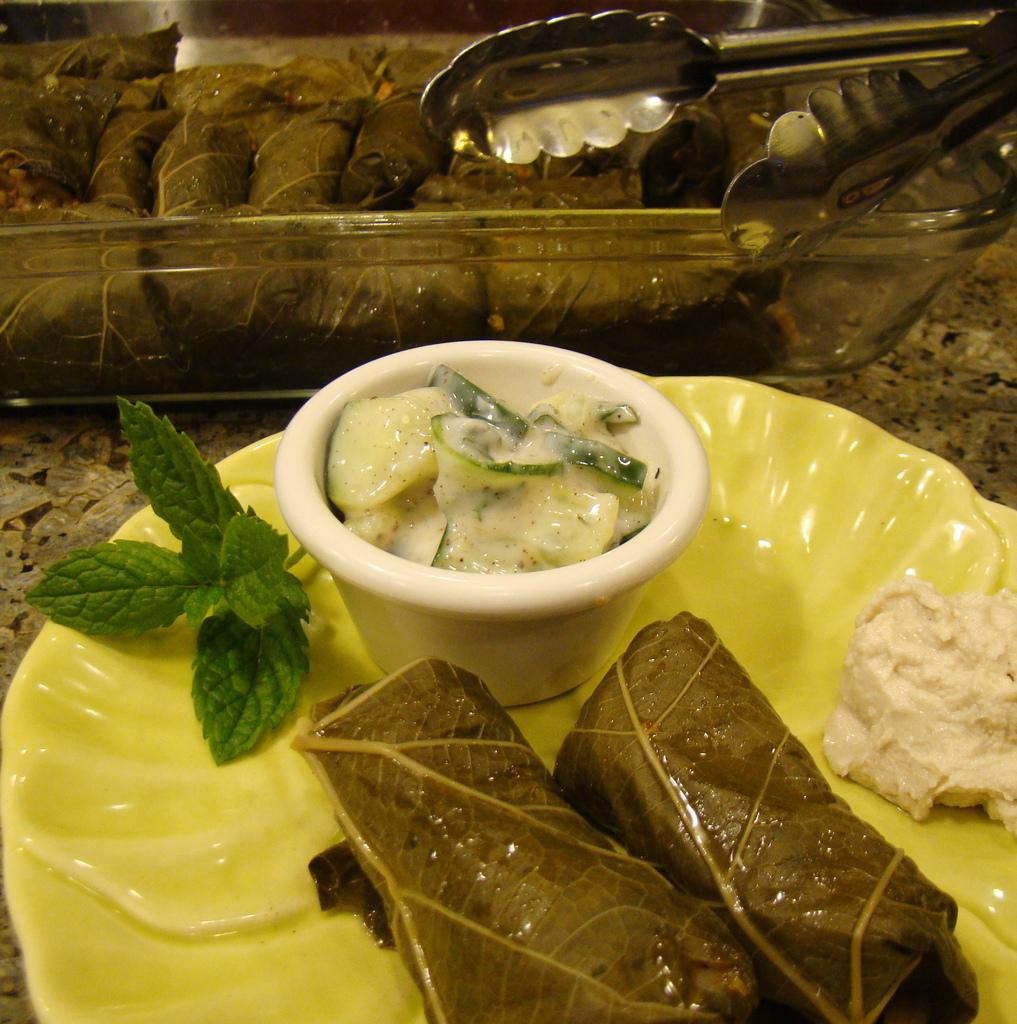What piece of furniture is present in the image? There is a table in the image. What is placed on the table? There is a plate and a tray on the table. What is on the tray? There is a food item on the tray. What type of approval is required to use the thumb in the image? There is no mention of a thumb or any approval process in the image. 